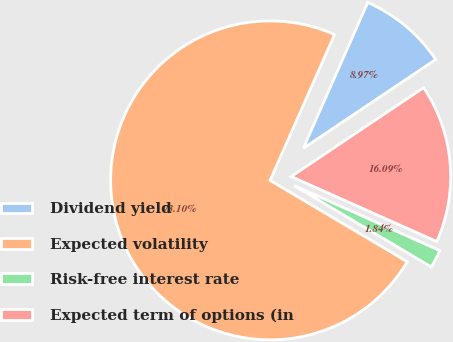Convert chart. <chart><loc_0><loc_0><loc_500><loc_500><pie_chart><fcel>Dividend yield<fcel>Expected volatility<fcel>Risk-free interest rate<fcel>Expected term of options (in<nl><fcel>8.97%<fcel>73.09%<fcel>1.84%<fcel>16.09%<nl></chart> 